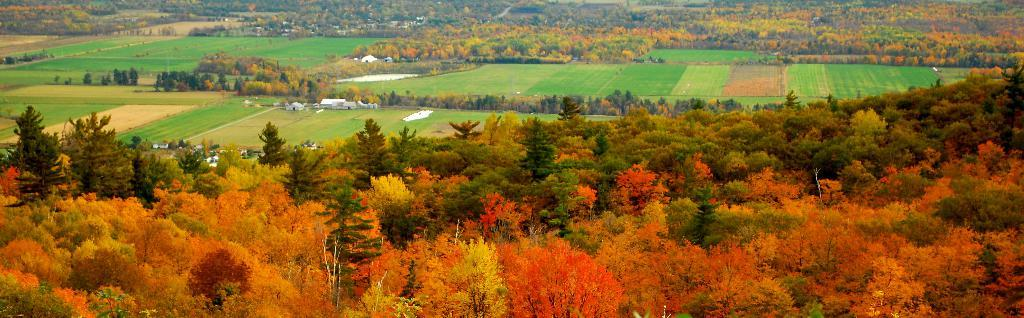What type of vegetation is visible in the image? There are trees in the image. What type of ground cover is visible in the image? There is grass in the image. What type of structures are visible in the image? There are houses in the image. Can you describe any other objects visible in the image? There are unspecified objects in the image. How many servants are visible in the image? There is no mention of servants in the image, so it is not possible to answer that question. 